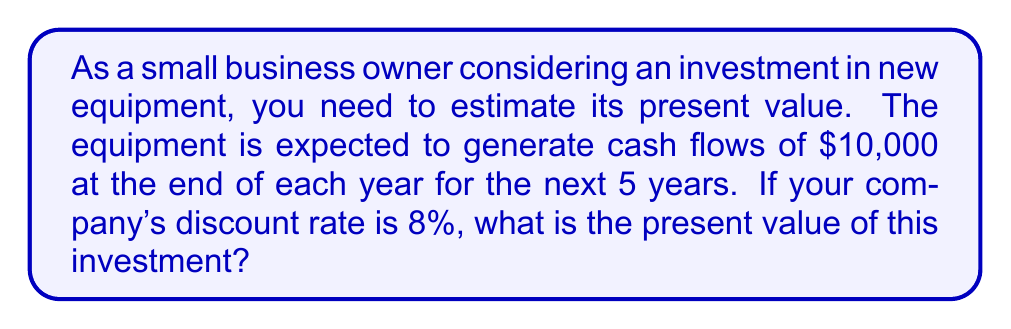Show me your answer to this math problem. To solve this problem, we need to use the present value formula for an annuity, since we have equal cash flows over a fixed period. The formula is:

$$PV = C \times \frac{1 - (1 + r)^{-n}}{r}$$

Where:
$PV$ = Present Value
$C$ = Cash flow per period
$r$ = Discount rate
$n$ = Number of periods

Given:
$C = \$10,000$
$r = 8\% = 0.08$
$n = 5$ years

Let's plug these values into the formula:

$$PV = 10,000 \times \frac{1 - (1 + 0.08)^{-5}}{0.08}$$

Now, let's solve step-by-step:

1. Calculate $(1 + 0.08)^{-5}$:
   $$(1.08)^{-5} = 0.6805556$$

2. Subtract this value from 1:
   $$1 - 0.6805556 = 0.3194444$$

3. Divide by the discount rate:
   $$\frac{0.3194444}{0.08} = 3.9930555$$

4. Multiply by the cash flow:
   $$10,000 \times 3.9930555 = 39,930.56$$

Therefore, the present value of the investment is $39,930.56.
Answer: $39,930.56 